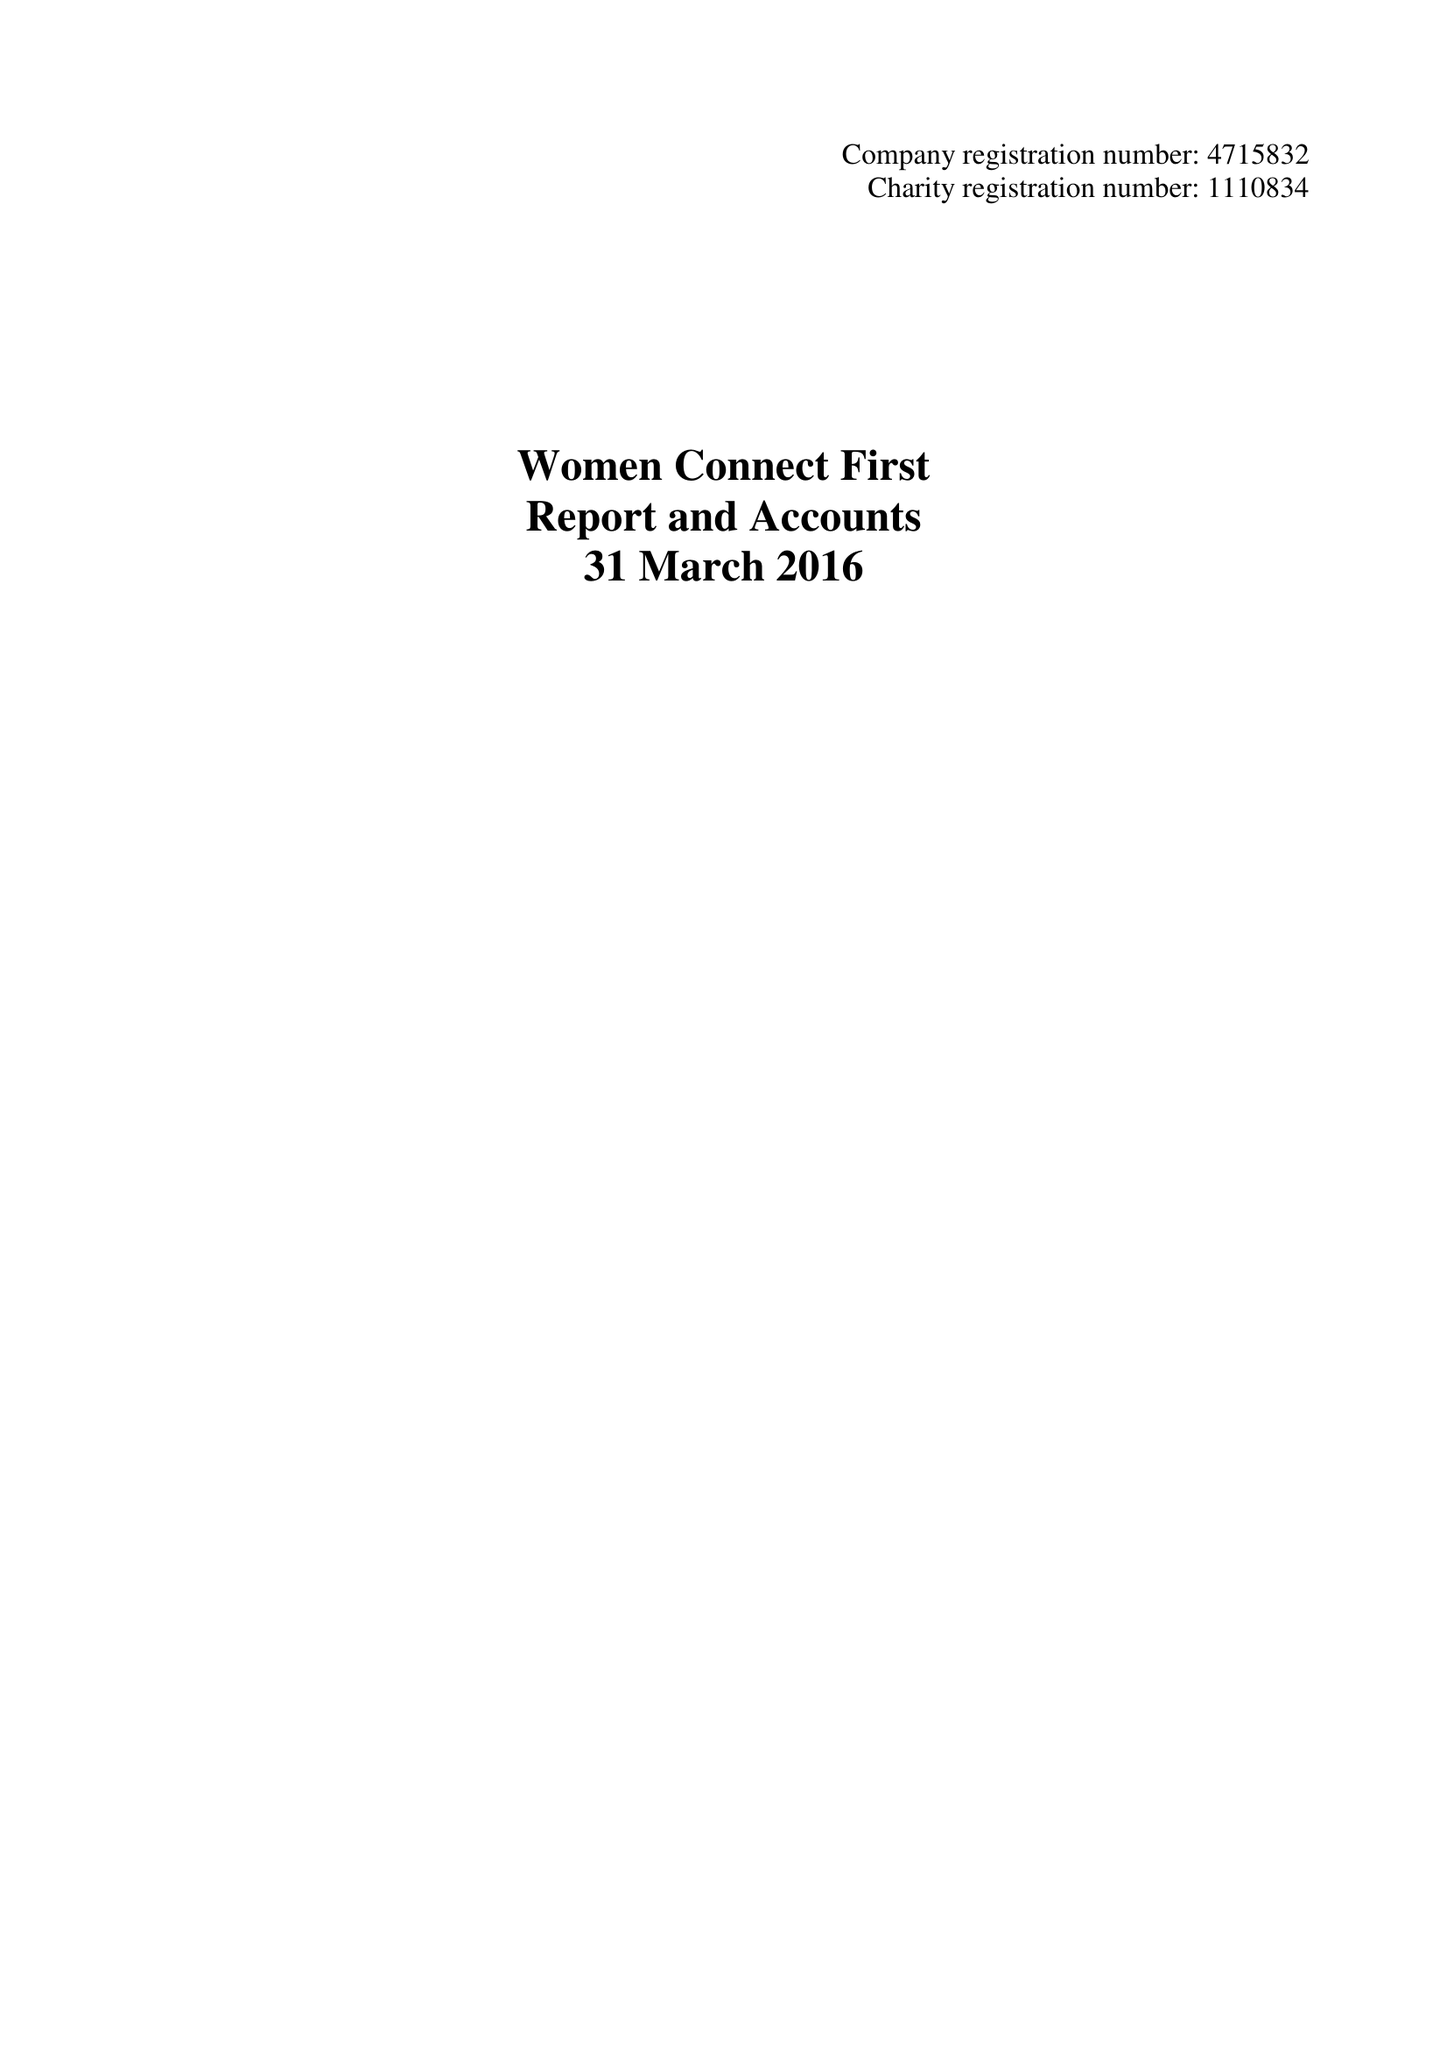What is the value for the charity_name?
Answer the question using a single word or phrase. Women Connect First Ltd. 